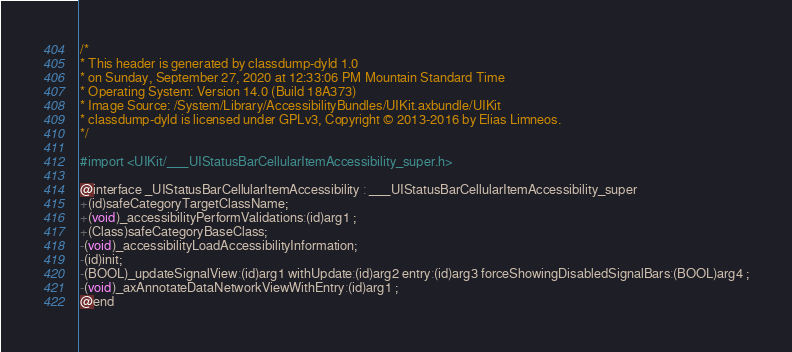Convert code to text. <code><loc_0><loc_0><loc_500><loc_500><_C_>/*
* This header is generated by classdump-dyld 1.0
* on Sunday, September 27, 2020 at 12:33:06 PM Mountain Standard Time
* Operating System: Version 14.0 (Build 18A373)
* Image Source: /System/Library/AccessibilityBundles/UIKit.axbundle/UIKit
* classdump-dyld is licensed under GPLv3, Copyright © 2013-2016 by Elias Limneos.
*/

#import <UIKit/___UIStatusBarCellularItemAccessibility_super.h>

@interface _UIStatusBarCellularItemAccessibility : ___UIStatusBarCellularItemAccessibility_super
+(id)safeCategoryTargetClassName;
+(void)_accessibilityPerformValidations:(id)arg1 ;
+(Class)safeCategoryBaseClass;
-(void)_accessibilityLoadAccessibilityInformation;
-(id)init;
-(BOOL)_updateSignalView:(id)arg1 withUpdate:(id)arg2 entry:(id)arg3 forceShowingDisabledSignalBars:(BOOL)arg4 ;
-(void)_axAnnotateDataNetworkViewWithEntry:(id)arg1 ;
@end

</code> 